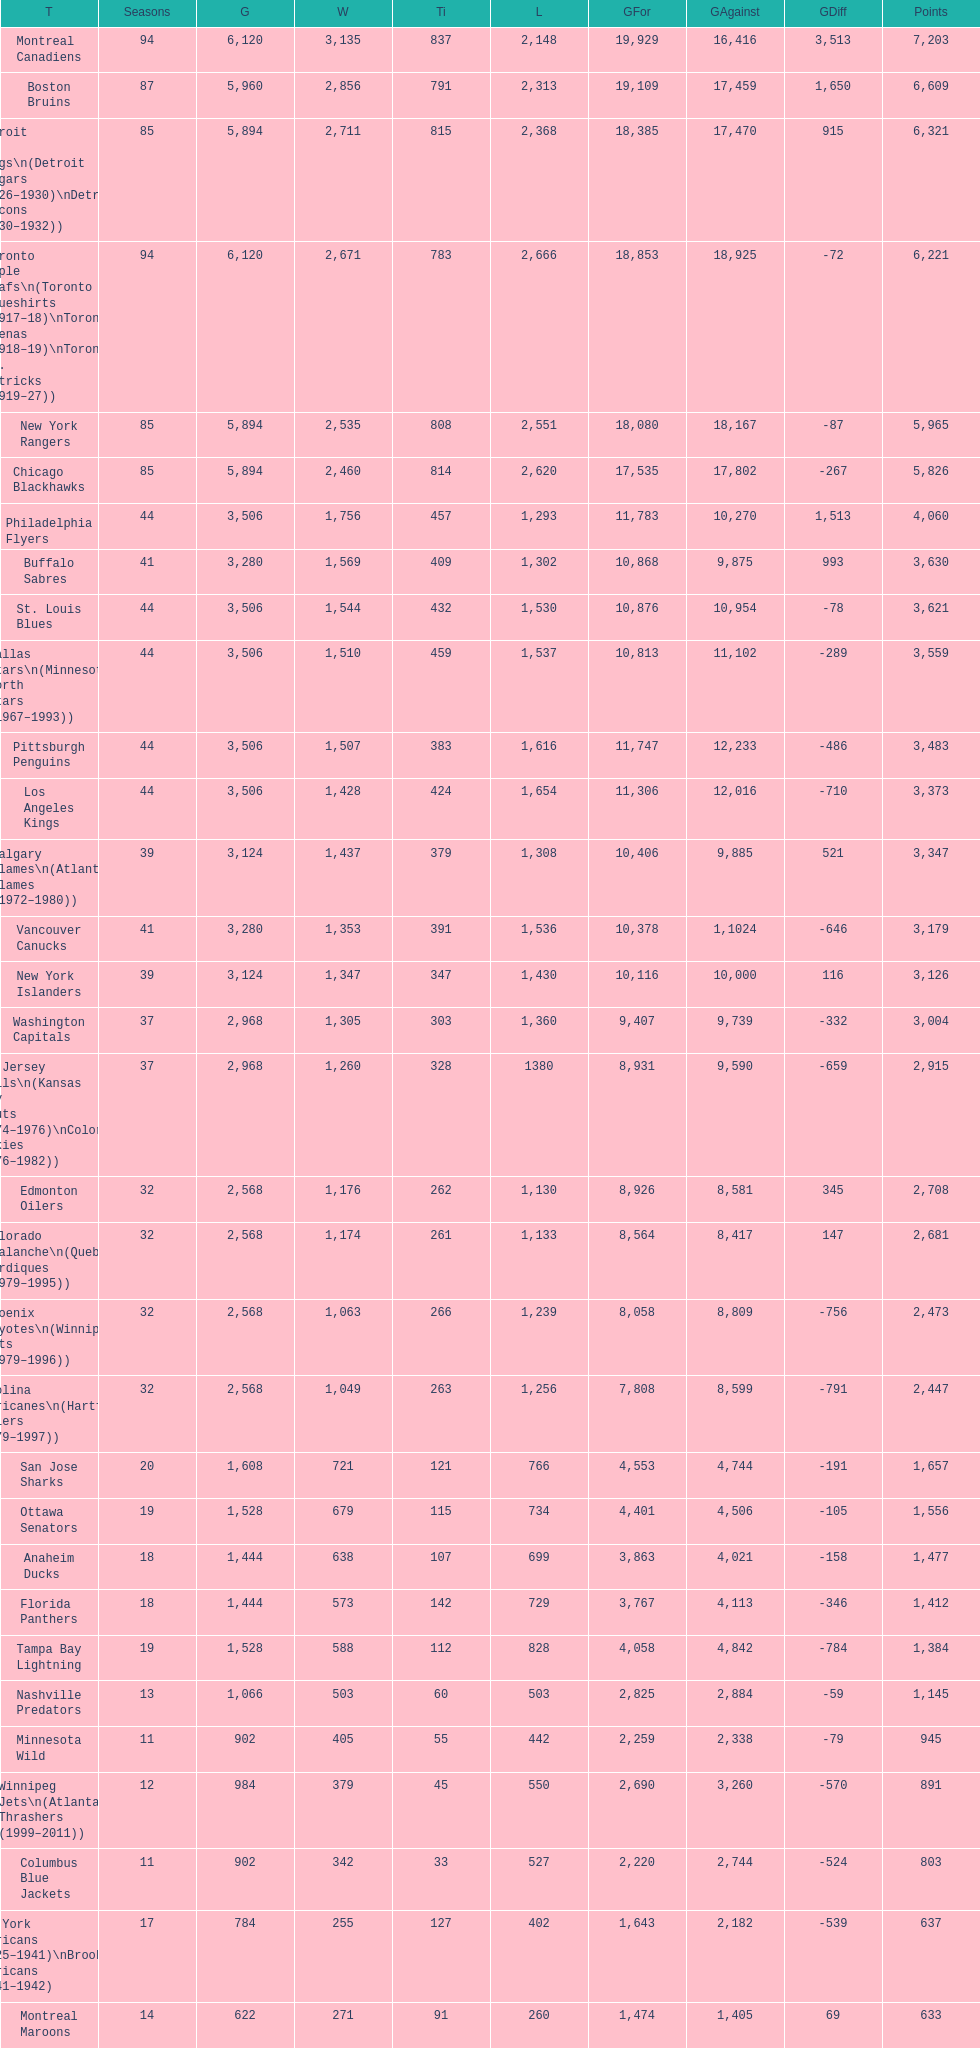Who is at the top of the list? Montreal Canadiens. 